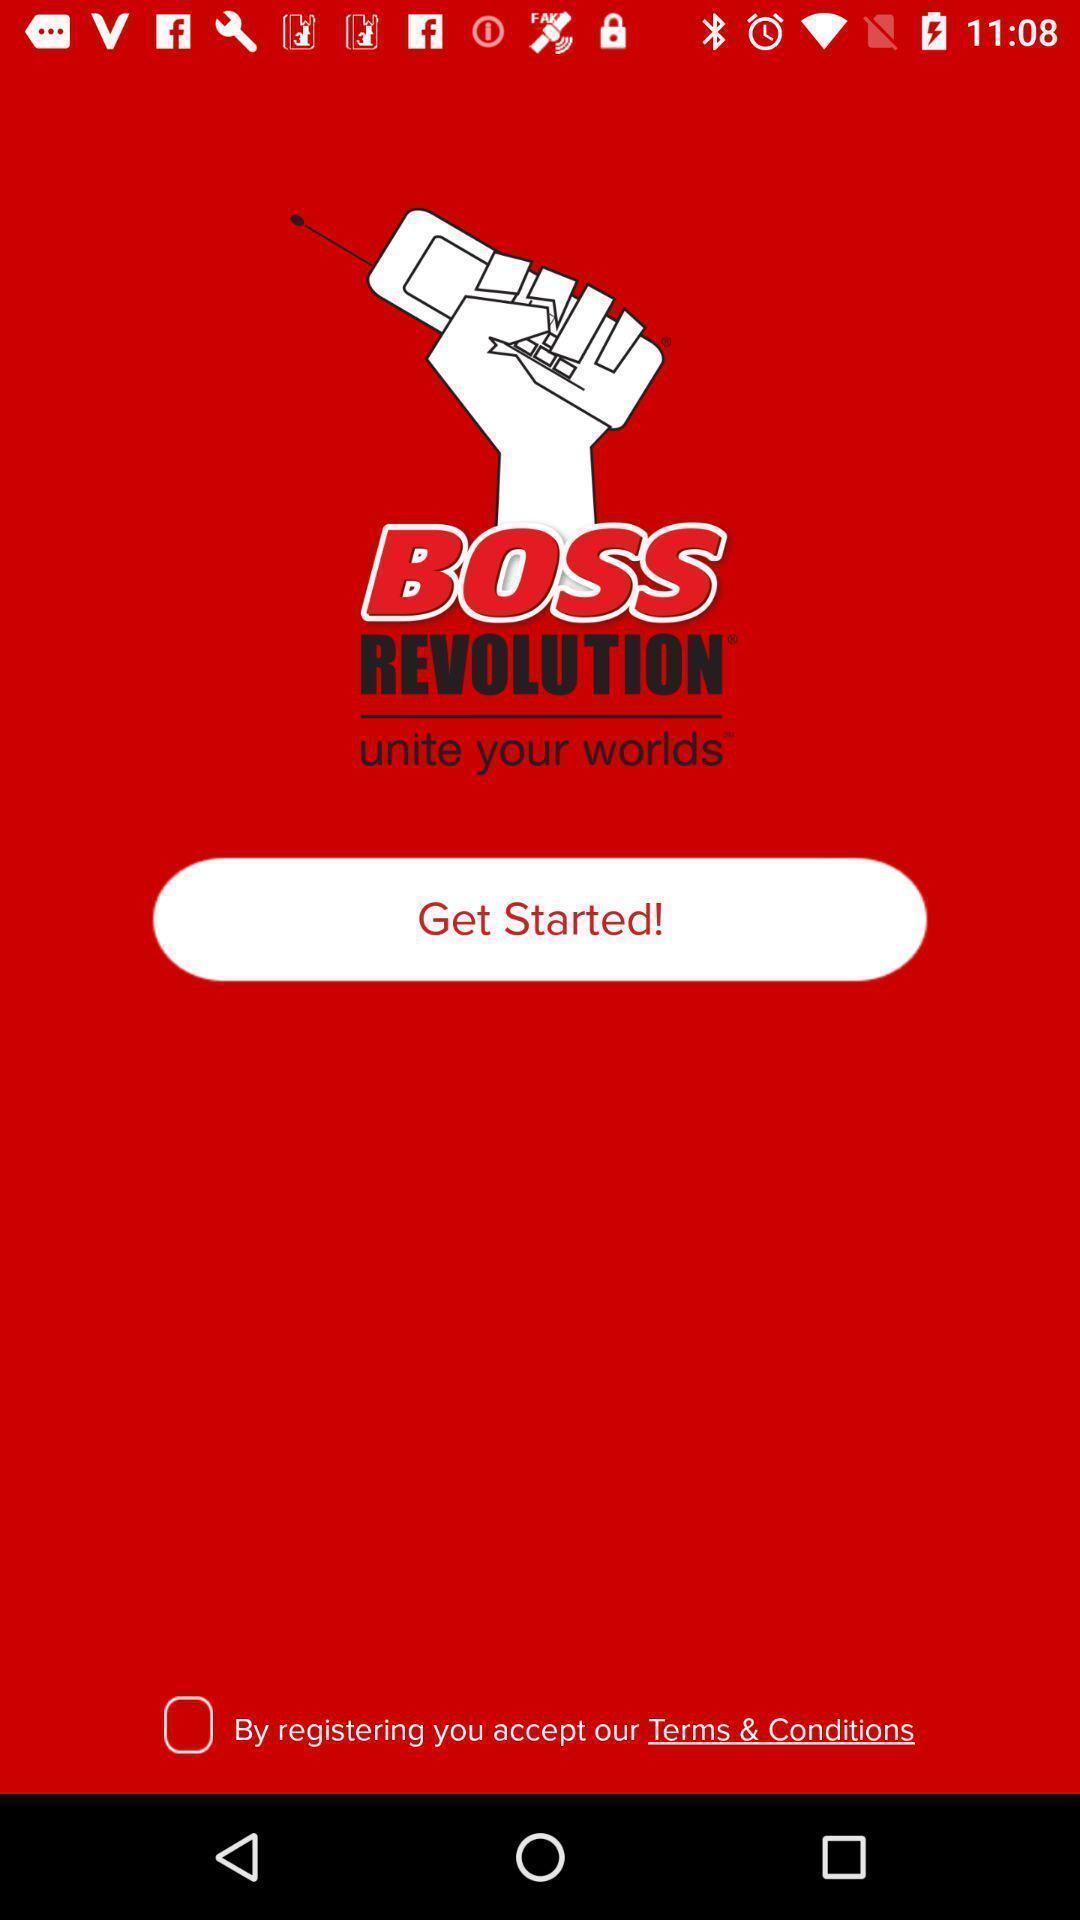Describe the content in this image. Welcome page of social app. 